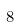Convert formula to latex. <formula><loc_0><loc_0><loc_500><loc_500>8</formula> 